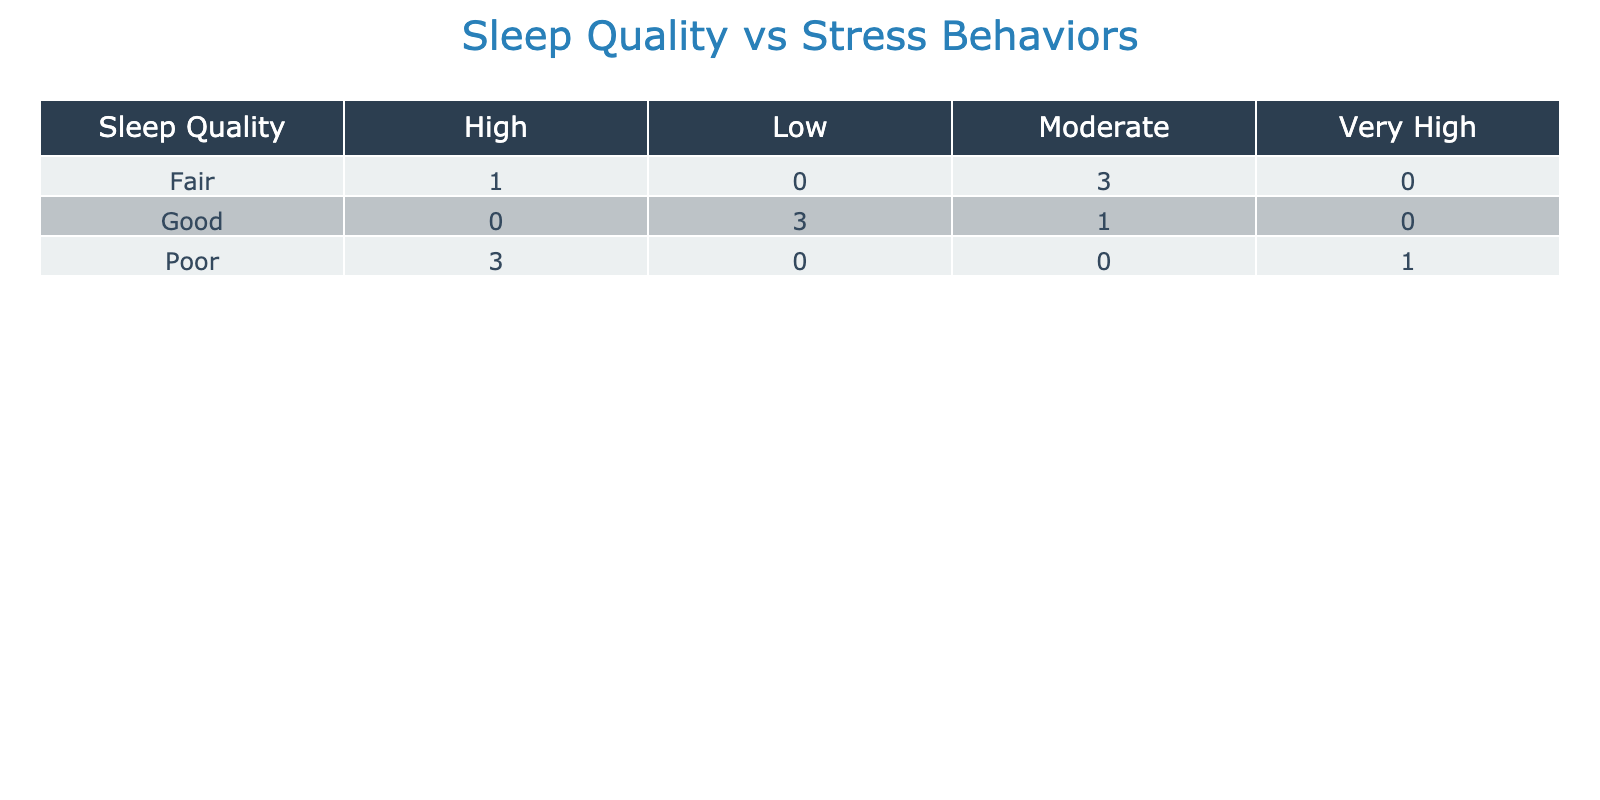What is the number of individuals with good sleep quality exhibiting low stress behaviors? In the table, we look under the "Good" category in the "Stress Behaviors" column and count the occurrences of "Low." There are 2 occurrences.
Answer: 2 How many individuals reported poor sleep quality and high stress behaviors? In the "Poor" category under "Stress Behaviors," we count the occurrences of "High," which appears 3 times.
Answer: 3 What is the total number of individuals who have fair sleep quality? We look at the "Fair" category in the "Sleep Quality" column. There are 4 individuals listed under this category.
Answer: 4 Is there any individual with good sleep quality who also has very high stress behaviors? Upon scanning the table, there are no entries for "Good" sleep quality and "Very High" stress behaviors, confirming this statement is false.
Answer: No What is the average cortisol level for individuals with poor sleep quality? We look under the "Poor" category and extract the cortisol levels: 9.5, 10.0, and 8.8. The sum is 28.3, and dividing by 3 gives an average of 9.43.
Answer: 9.43 How many individuals have moderate stress behaviors across all sleep quality categories? We check each sleep quality category for occurrences of "Moderate," which appears 3 times in total (Good 1, Fair 2).
Answer: 3 Which sleep quality category has the highest number of individuals exhibiting high stress behaviors? In the "High" stress behaviors, "Poor" has the highest occurrences (3). Fair has 1 occurrence while Good has none.
Answer: Poor What is the total number of individuals with low cortisol levels? Reviewing the cortisol levels, we note that "Low" is recorded under Good sleep quality (5.0 and 5.2). Thus, there are 2 total individuals with low cortisol levels.
Answer: 2 Is there a correlation between poor sleep quality and very high cortisol levels? Yes, we find that individuals categorized as "Poor" have cortisol levels of 9.5, 10.0, and 8.8—all indicating higher cortisol levels—and they are evidently linked to higher stress behaviors.
Answer: Yes 